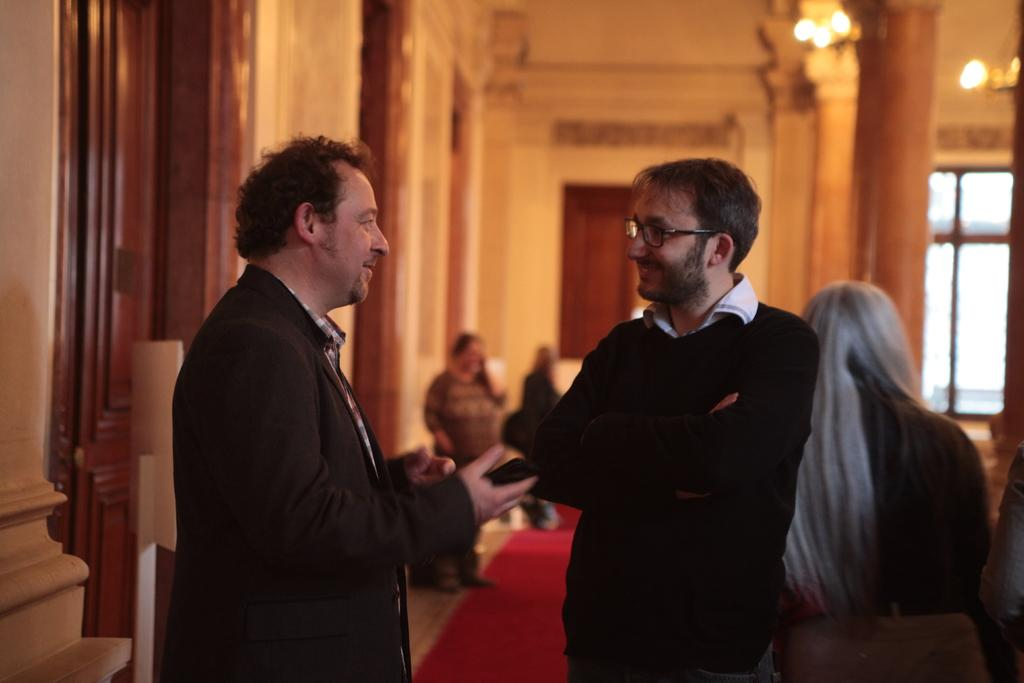What is the main subject of the image? There is a group of people on the floor. What can be seen in the background of the image? There is a wall, pillars, a door, lights, and a window in the background. What type of location is the image taken in? The image is taken in a hall. What type of toothpaste is being used by the people in the image? There is no toothpaste present in the image; it features a group of people on the floor in a hall. Can you describe the zephyr blowing through the hall in the image? There is no mention of a zephyr or any wind in the image; it is focused on the group of people and the background elements. 